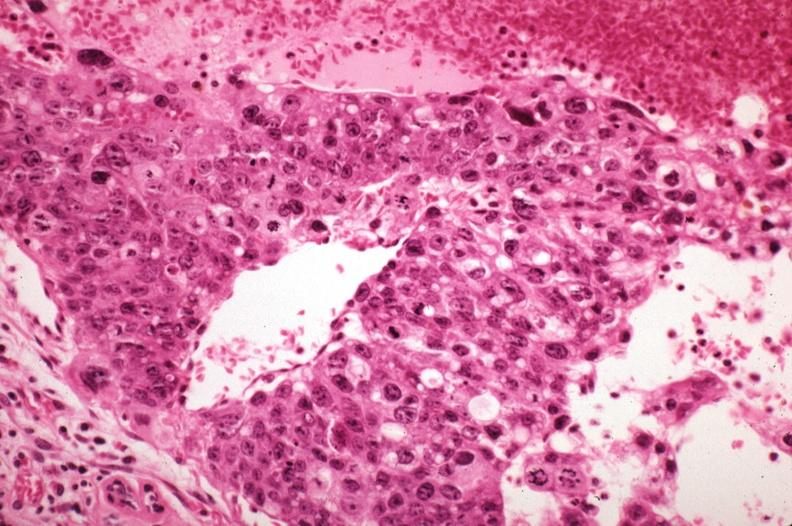does this image show metastatic choriocarcinoma with pleomorphism?
Answer the question using a single word or phrase. Yes 